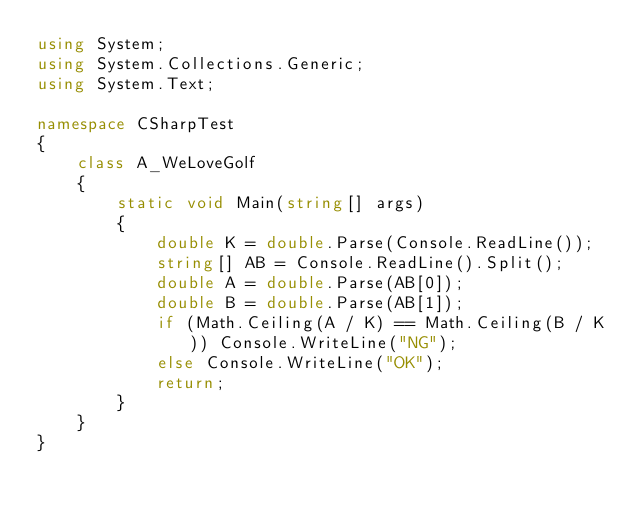Convert code to text. <code><loc_0><loc_0><loc_500><loc_500><_C#_>using System;
using System.Collections.Generic;
using System.Text;

namespace CSharpTest
{
    class A_WeLoveGolf
    {
        static void Main(string[] args)
        {
            double K = double.Parse(Console.ReadLine());
            string[] AB = Console.ReadLine().Split();
            double A = double.Parse(AB[0]);
            double B = double.Parse(AB[1]);
            if (Math.Ceiling(A / K) == Math.Ceiling(B / K)) Console.WriteLine("NG");
            else Console.WriteLine("OK");
            return;
        }
    }
}
</code> 